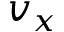<formula> <loc_0><loc_0><loc_500><loc_500>v _ { x }</formula> 